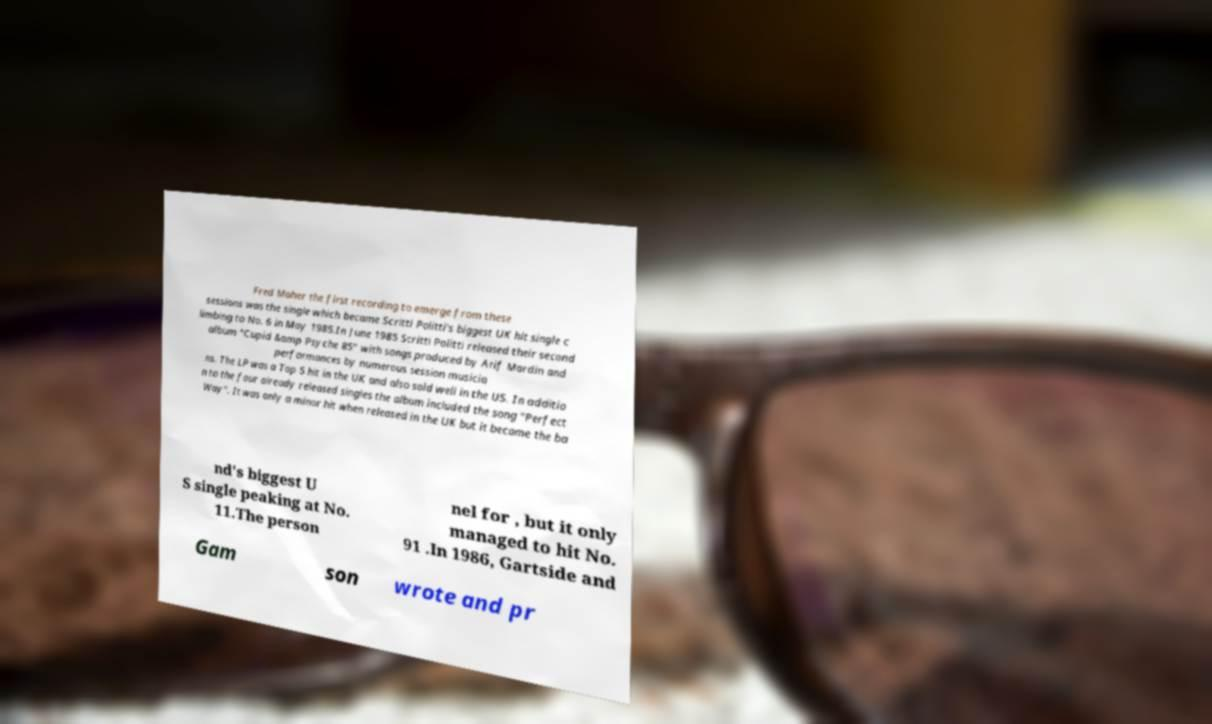Please identify and transcribe the text found in this image. Fred Maher the first recording to emerge from these sessions was the single which became Scritti Politti's biggest UK hit single c limbing to No. 6 in May 1985.In June 1985 Scritti Politti released their second album "Cupid &amp Psyche 85" with songs produced by Arif Mardin and performances by numerous session musicia ns. The LP was a Top 5 hit in the UK and also sold well in the US. In additio n to the four already released singles the album included the song "Perfect Way". It was only a minor hit when released in the UK but it became the ba nd's biggest U S single peaking at No. 11.The person nel for , but it only managed to hit No. 91 .In 1986, Gartside and Gam son wrote and pr 